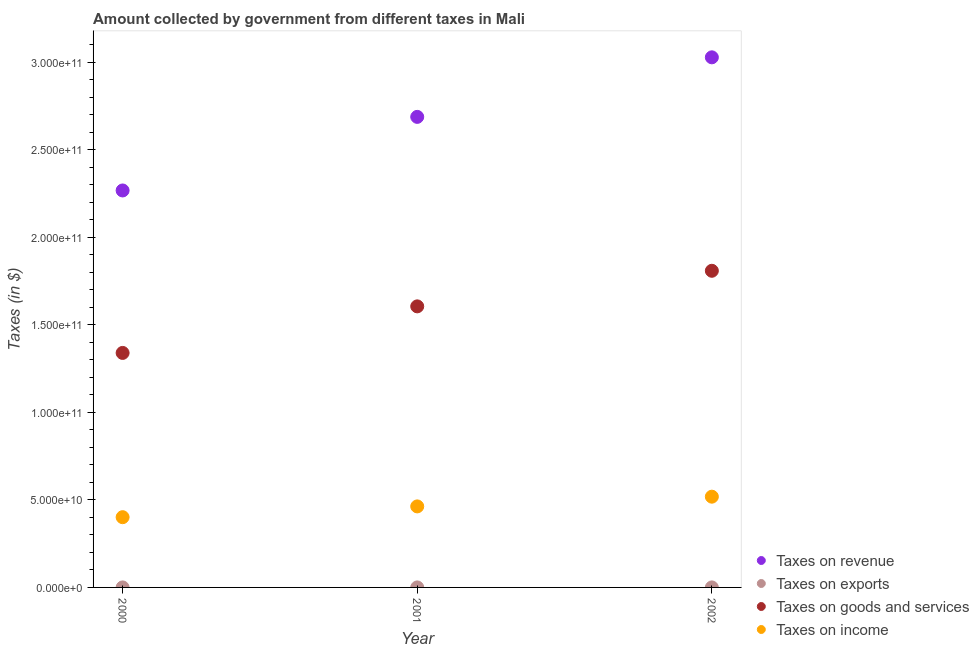Is the number of dotlines equal to the number of legend labels?
Ensure brevity in your answer.  Yes. What is the amount collected as tax on exports in 2001?
Provide a short and direct response. 4.41e+06. Across all years, what is the maximum amount collected as tax on revenue?
Offer a very short reply. 3.03e+11. Across all years, what is the minimum amount collected as tax on goods?
Make the answer very short. 1.34e+11. In which year was the amount collected as tax on exports minimum?
Your response must be concise. 2000. What is the total amount collected as tax on income in the graph?
Provide a short and direct response. 1.38e+11. What is the difference between the amount collected as tax on exports in 2000 and that in 2001?
Make the answer very short. -4.12e+06. What is the difference between the amount collected as tax on income in 2001 and the amount collected as tax on exports in 2002?
Make the answer very short. 4.63e+1. What is the average amount collected as tax on goods per year?
Make the answer very short. 1.59e+11. In the year 2001, what is the difference between the amount collected as tax on revenue and amount collected as tax on income?
Give a very brief answer. 2.23e+11. In how many years, is the amount collected as tax on revenue greater than 150000000000 $?
Offer a terse response. 3. What is the ratio of the amount collected as tax on revenue in 2001 to that in 2002?
Ensure brevity in your answer.  0.89. Is the difference between the amount collected as tax on goods in 2000 and 2002 greater than the difference between the amount collected as tax on revenue in 2000 and 2002?
Your answer should be very brief. Yes. What is the difference between the highest and the second highest amount collected as tax on income?
Your answer should be very brief. 5.56e+09. What is the difference between the highest and the lowest amount collected as tax on income?
Make the answer very short. 1.17e+1. In how many years, is the amount collected as tax on exports greater than the average amount collected as tax on exports taken over all years?
Provide a succinct answer. 2. Is the sum of the amount collected as tax on income in 2000 and 2001 greater than the maximum amount collected as tax on revenue across all years?
Ensure brevity in your answer.  No. Is it the case that in every year, the sum of the amount collected as tax on revenue and amount collected as tax on income is greater than the sum of amount collected as tax on goods and amount collected as tax on exports?
Your answer should be compact. No. Does the amount collected as tax on goods monotonically increase over the years?
Provide a short and direct response. Yes. Is the amount collected as tax on income strictly less than the amount collected as tax on revenue over the years?
Keep it short and to the point. Yes. How many years are there in the graph?
Your answer should be compact. 3. Are the values on the major ticks of Y-axis written in scientific E-notation?
Ensure brevity in your answer.  Yes. Does the graph contain grids?
Provide a succinct answer. No. How many legend labels are there?
Keep it short and to the point. 4. How are the legend labels stacked?
Your answer should be very brief. Vertical. What is the title of the graph?
Provide a succinct answer. Amount collected by government from different taxes in Mali. What is the label or title of the Y-axis?
Make the answer very short. Taxes (in $). What is the Taxes (in $) in Taxes on revenue in 2000?
Provide a succinct answer. 2.27e+11. What is the Taxes (in $) of Taxes on exports in 2000?
Make the answer very short. 2.89e+05. What is the Taxes (in $) of Taxes on goods and services in 2000?
Provide a short and direct response. 1.34e+11. What is the Taxes (in $) in Taxes on income in 2000?
Your response must be concise. 4.01e+1. What is the Taxes (in $) of Taxes on revenue in 2001?
Provide a short and direct response. 2.69e+11. What is the Taxes (in $) of Taxes on exports in 2001?
Ensure brevity in your answer.  4.41e+06. What is the Taxes (in $) of Taxes on goods and services in 2001?
Your response must be concise. 1.61e+11. What is the Taxes (in $) in Taxes on income in 2001?
Make the answer very short. 4.63e+1. What is the Taxes (in $) of Taxes on revenue in 2002?
Your answer should be very brief. 3.03e+11. What is the Taxes (in $) of Taxes on exports in 2002?
Offer a very short reply. 8.52e+06. What is the Taxes (in $) in Taxes on goods and services in 2002?
Your response must be concise. 1.81e+11. What is the Taxes (in $) in Taxes on income in 2002?
Offer a terse response. 5.19e+1. Across all years, what is the maximum Taxes (in $) of Taxes on revenue?
Provide a short and direct response. 3.03e+11. Across all years, what is the maximum Taxes (in $) in Taxes on exports?
Offer a terse response. 8.52e+06. Across all years, what is the maximum Taxes (in $) of Taxes on goods and services?
Your response must be concise. 1.81e+11. Across all years, what is the maximum Taxes (in $) of Taxes on income?
Provide a succinct answer. 5.19e+1. Across all years, what is the minimum Taxes (in $) in Taxes on revenue?
Make the answer very short. 2.27e+11. Across all years, what is the minimum Taxes (in $) in Taxes on exports?
Your answer should be compact. 2.89e+05. Across all years, what is the minimum Taxes (in $) of Taxes on goods and services?
Give a very brief answer. 1.34e+11. Across all years, what is the minimum Taxes (in $) of Taxes on income?
Offer a very short reply. 4.01e+1. What is the total Taxes (in $) in Taxes on revenue in the graph?
Offer a very short reply. 7.99e+11. What is the total Taxes (in $) in Taxes on exports in the graph?
Offer a very short reply. 1.32e+07. What is the total Taxes (in $) in Taxes on goods and services in the graph?
Offer a very short reply. 4.76e+11. What is the total Taxes (in $) in Taxes on income in the graph?
Provide a short and direct response. 1.38e+11. What is the difference between the Taxes (in $) of Taxes on revenue in 2000 and that in 2001?
Your answer should be compact. -4.21e+1. What is the difference between the Taxes (in $) of Taxes on exports in 2000 and that in 2001?
Offer a very short reply. -4.12e+06. What is the difference between the Taxes (in $) in Taxes on goods and services in 2000 and that in 2001?
Ensure brevity in your answer.  -2.66e+1. What is the difference between the Taxes (in $) in Taxes on income in 2000 and that in 2001?
Provide a succinct answer. -6.16e+09. What is the difference between the Taxes (in $) in Taxes on revenue in 2000 and that in 2002?
Your response must be concise. -7.61e+1. What is the difference between the Taxes (in $) in Taxes on exports in 2000 and that in 2002?
Give a very brief answer. -8.24e+06. What is the difference between the Taxes (in $) in Taxes on goods and services in 2000 and that in 2002?
Make the answer very short. -4.69e+1. What is the difference between the Taxes (in $) of Taxes on income in 2000 and that in 2002?
Keep it short and to the point. -1.17e+1. What is the difference between the Taxes (in $) in Taxes on revenue in 2001 and that in 2002?
Provide a succinct answer. -3.40e+1. What is the difference between the Taxes (in $) of Taxes on exports in 2001 and that in 2002?
Your answer should be very brief. -4.11e+06. What is the difference between the Taxes (in $) in Taxes on goods and services in 2001 and that in 2002?
Keep it short and to the point. -2.03e+1. What is the difference between the Taxes (in $) in Taxes on income in 2001 and that in 2002?
Ensure brevity in your answer.  -5.56e+09. What is the difference between the Taxes (in $) in Taxes on revenue in 2000 and the Taxes (in $) in Taxes on exports in 2001?
Your response must be concise. 2.27e+11. What is the difference between the Taxes (in $) in Taxes on revenue in 2000 and the Taxes (in $) in Taxes on goods and services in 2001?
Your response must be concise. 6.62e+1. What is the difference between the Taxes (in $) in Taxes on revenue in 2000 and the Taxes (in $) in Taxes on income in 2001?
Provide a succinct answer. 1.81e+11. What is the difference between the Taxes (in $) of Taxes on exports in 2000 and the Taxes (in $) of Taxes on goods and services in 2001?
Your answer should be very brief. -1.61e+11. What is the difference between the Taxes (in $) in Taxes on exports in 2000 and the Taxes (in $) in Taxes on income in 2001?
Offer a very short reply. -4.63e+1. What is the difference between the Taxes (in $) in Taxes on goods and services in 2000 and the Taxes (in $) in Taxes on income in 2001?
Provide a succinct answer. 8.77e+1. What is the difference between the Taxes (in $) of Taxes on revenue in 2000 and the Taxes (in $) of Taxes on exports in 2002?
Your answer should be compact. 2.27e+11. What is the difference between the Taxes (in $) of Taxes on revenue in 2000 and the Taxes (in $) of Taxes on goods and services in 2002?
Make the answer very short. 4.59e+1. What is the difference between the Taxes (in $) in Taxes on revenue in 2000 and the Taxes (in $) in Taxes on income in 2002?
Offer a very short reply. 1.75e+11. What is the difference between the Taxes (in $) of Taxes on exports in 2000 and the Taxes (in $) of Taxes on goods and services in 2002?
Give a very brief answer. -1.81e+11. What is the difference between the Taxes (in $) in Taxes on exports in 2000 and the Taxes (in $) in Taxes on income in 2002?
Your response must be concise. -5.19e+1. What is the difference between the Taxes (in $) in Taxes on goods and services in 2000 and the Taxes (in $) in Taxes on income in 2002?
Your answer should be compact. 8.21e+1. What is the difference between the Taxes (in $) of Taxes on revenue in 2001 and the Taxes (in $) of Taxes on exports in 2002?
Make the answer very short. 2.69e+11. What is the difference between the Taxes (in $) of Taxes on revenue in 2001 and the Taxes (in $) of Taxes on goods and services in 2002?
Provide a short and direct response. 8.80e+1. What is the difference between the Taxes (in $) of Taxes on revenue in 2001 and the Taxes (in $) of Taxes on income in 2002?
Your answer should be very brief. 2.17e+11. What is the difference between the Taxes (in $) in Taxes on exports in 2001 and the Taxes (in $) in Taxes on goods and services in 2002?
Make the answer very short. -1.81e+11. What is the difference between the Taxes (in $) of Taxes on exports in 2001 and the Taxes (in $) of Taxes on income in 2002?
Ensure brevity in your answer.  -5.19e+1. What is the difference between the Taxes (in $) of Taxes on goods and services in 2001 and the Taxes (in $) of Taxes on income in 2002?
Offer a terse response. 1.09e+11. What is the average Taxes (in $) in Taxes on revenue per year?
Ensure brevity in your answer.  2.66e+11. What is the average Taxes (in $) in Taxes on exports per year?
Offer a terse response. 4.41e+06. What is the average Taxes (in $) of Taxes on goods and services per year?
Your response must be concise. 1.59e+11. What is the average Taxes (in $) in Taxes on income per year?
Your answer should be very brief. 4.61e+1. In the year 2000, what is the difference between the Taxes (in $) of Taxes on revenue and Taxes (in $) of Taxes on exports?
Your answer should be compact. 2.27e+11. In the year 2000, what is the difference between the Taxes (in $) in Taxes on revenue and Taxes (in $) in Taxes on goods and services?
Provide a short and direct response. 9.28e+1. In the year 2000, what is the difference between the Taxes (in $) of Taxes on revenue and Taxes (in $) of Taxes on income?
Provide a short and direct response. 1.87e+11. In the year 2000, what is the difference between the Taxes (in $) in Taxes on exports and Taxes (in $) in Taxes on goods and services?
Offer a terse response. -1.34e+11. In the year 2000, what is the difference between the Taxes (in $) of Taxes on exports and Taxes (in $) of Taxes on income?
Provide a succinct answer. -4.01e+1. In the year 2000, what is the difference between the Taxes (in $) of Taxes on goods and services and Taxes (in $) of Taxes on income?
Give a very brief answer. 9.39e+1. In the year 2001, what is the difference between the Taxes (in $) of Taxes on revenue and Taxes (in $) of Taxes on exports?
Your response must be concise. 2.69e+11. In the year 2001, what is the difference between the Taxes (in $) in Taxes on revenue and Taxes (in $) in Taxes on goods and services?
Keep it short and to the point. 1.08e+11. In the year 2001, what is the difference between the Taxes (in $) in Taxes on revenue and Taxes (in $) in Taxes on income?
Ensure brevity in your answer.  2.23e+11. In the year 2001, what is the difference between the Taxes (in $) in Taxes on exports and Taxes (in $) in Taxes on goods and services?
Ensure brevity in your answer.  -1.61e+11. In the year 2001, what is the difference between the Taxes (in $) in Taxes on exports and Taxes (in $) in Taxes on income?
Your answer should be very brief. -4.63e+1. In the year 2001, what is the difference between the Taxes (in $) of Taxes on goods and services and Taxes (in $) of Taxes on income?
Your answer should be very brief. 1.14e+11. In the year 2002, what is the difference between the Taxes (in $) in Taxes on revenue and Taxes (in $) in Taxes on exports?
Make the answer very short. 3.03e+11. In the year 2002, what is the difference between the Taxes (in $) of Taxes on revenue and Taxes (in $) of Taxes on goods and services?
Your answer should be compact. 1.22e+11. In the year 2002, what is the difference between the Taxes (in $) of Taxes on revenue and Taxes (in $) of Taxes on income?
Your response must be concise. 2.51e+11. In the year 2002, what is the difference between the Taxes (in $) of Taxes on exports and Taxes (in $) of Taxes on goods and services?
Keep it short and to the point. -1.81e+11. In the year 2002, what is the difference between the Taxes (in $) of Taxes on exports and Taxes (in $) of Taxes on income?
Ensure brevity in your answer.  -5.18e+1. In the year 2002, what is the difference between the Taxes (in $) in Taxes on goods and services and Taxes (in $) in Taxes on income?
Give a very brief answer. 1.29e+11. What is the ratio of the Taxes (in $) in Taxes on revenue in 2000 to that in 2001?
Your response must be concise. 0.84. What is the ratio of the Taxes (in $) of Taxes on exports in 2000 to that in 2001?
Provide a succinct answer. 0.07. What is the ratio of the Taxes (in $) in Taxes on goods and services in 2000 to that in 2001?
Ensure brevity in your answer.  0.83. What is the ratio of the Taxes (in $) of Taxes on income in 2000 to that in 2001?
Keep it short and to the point. 0.87. What is the ratio of the Taxes (in $) in Taxes on revenue in 2000 to that in 2002?
Provide a succinct answer. 0.75. What is the ratio of the Taxes (in $) of Taxes on exports in 2000 to that in 2002?
Offer a terse response. 0.03. What is the ratio of the Taxes (in $) in Taxes on goods and services in 2000 to that in 2002?
Your answer should be compact. 0.74. What is the ratio of the Taxes (in $) of Taxes on income in 2000 to that in 2002?
Your answer should be compact. 0.77. What is the ratio of the Taxes (in $) in Taxes on revenue in 2001 to that in 2002?
Provide a short and direct response. 0.89. What is the ratio of the Taxes (in $) of Taxes on exports in 2001 to that in 2002?
Your response must be concise. 0.52. What is the ratio of the Taxes (in $) of Taxes on goods and services in 2001 to that in 2002?
Your answer should be very brief. 0.89. What is the ratio of the Taxes (in $) of Taxes on income in 2001 to that in 2002?
Offer a terse response. 0.89. What is the difference between the highest and the second highest Taxes (in $) of Taxes on revenue?
Ensure brevity in your answer.  3.40e+1. What is the difference between the highest and the second highest Taxes (in $) in Taxes on exports?
Your response must be concise. 4.11e+06. What is the difference between the highest and the second highest Taxes (in $) in Taxes on goods and services?
Keep it short and to the point. 2.03e+1. What is the difference between the highest and the second highest Taxes (in $) of Taxes on income?
Your answer should be compact. 5.56e+09. What is the difference between the highest and the lowest Taxes (in $) of Taxes on revenue?
Keep it short and to the point. 7.61e+1. What is the difference between the highest and the lowest Taxes (in $) in Taxes on exports?
Give a very brief answer. 8.24e+06. What is the difference between the highest and the lowest Taxes (in $) in Taxes on goods and services?
Make the answer very short. 4.69e+1. What is the difference between the highest and the lowest Taxes (in $) in Taxes on income?
Make the answer very short. 1.17e+1. 